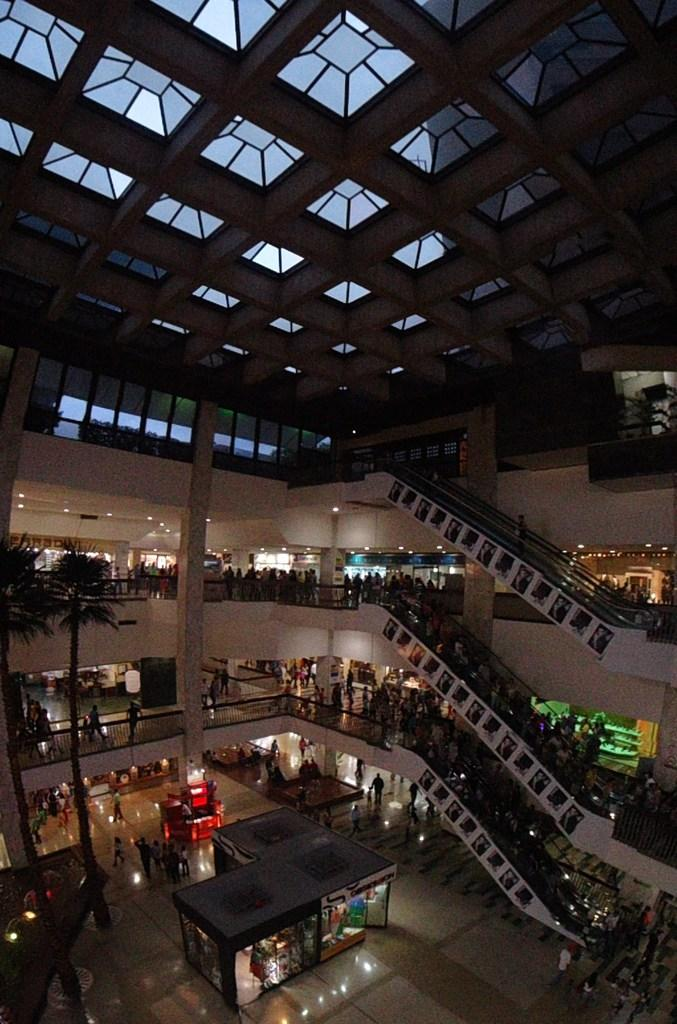How many people can be seen in the image? There are people in the image, but the exact number cannot be determined from the provided facts. What type of surface is visible beneath the people? There is a floor visible in the image. What type of vegetation is present in the image? There are trees in the image. What architectural features can be seen in the image? There are pillars, lights, railings, and a glass roof visible in the image. What objects are present in the image? There are objects in the image, but their specific nature cannot be determined from the provided facts. What type of insurance policy is being discussed by the people in the image? There is no indication in the image that the people are discussing any insurance policies. Can you see a hose being used by anyone in the image? There is no hose present in the image. 